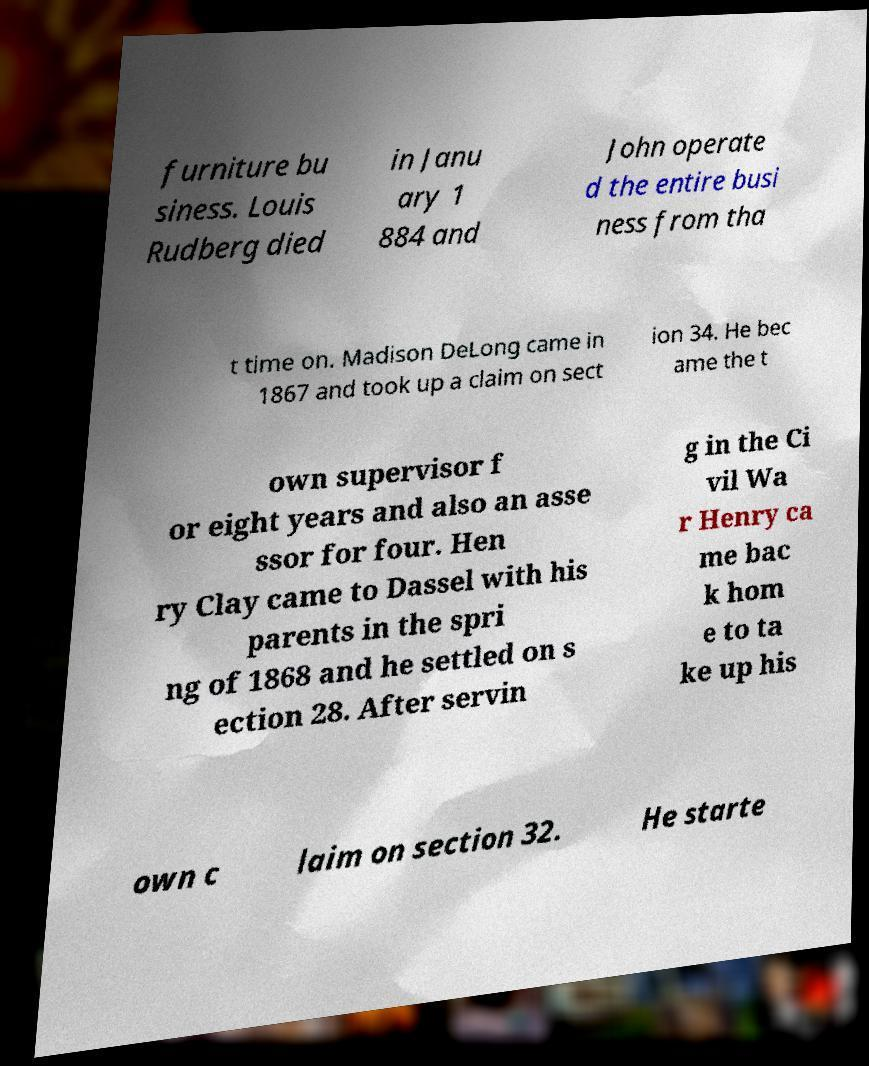Can you accurately transcribe the text from the provided image for me? furniture bu siness. Louis Rudberg died in Janu ary 1 884 and John operate d the entire busi ness from tha t time on. Madison DeLong came in 1867 and took up a claim on sect ion 34. He bec ame the t own supervisor f or eight years and also an asse ssor for four. Hen ry Clay came to Dassel with his parents in the spri ng of 1868 and he settled on s ection 28. After servin g in the Ci vil Wa r Henry ca me bac k hom e to ta ke up his own c laim on section 32. He starte 